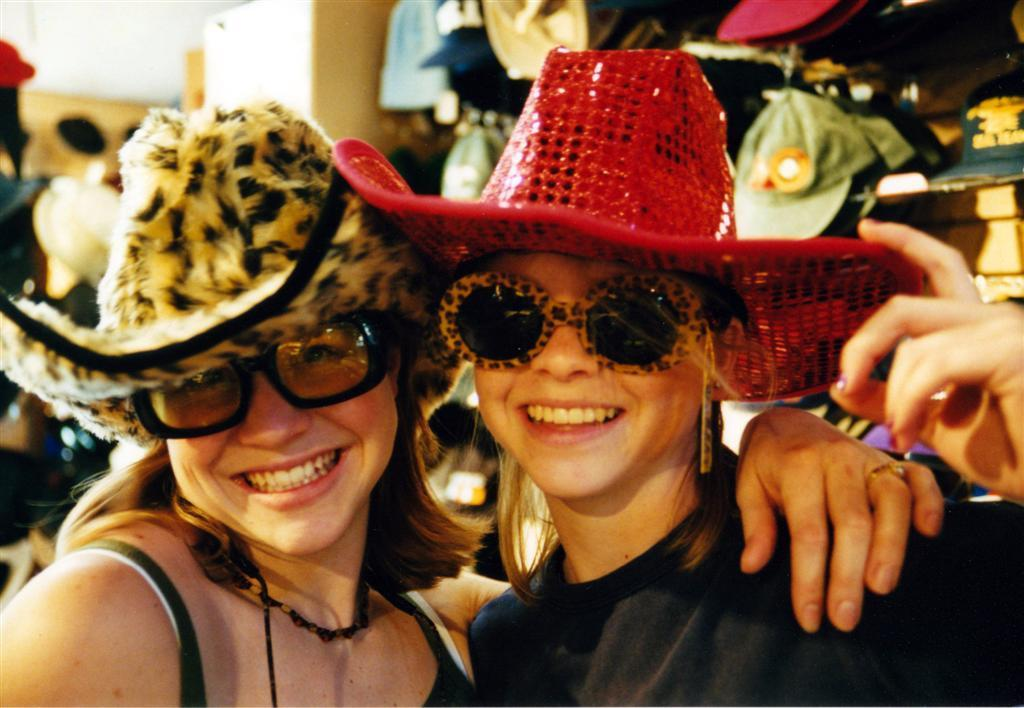How many people are in the image? There are two persons in the image. What are the persons wearing on their heads? Both persons are wearing caps. What expressions do the persons have in the image? Both persons are smiling. What type of parcel is being delivered by the persons in the image? There is no parcel visible in the image, and the persons are not delivering anything. What route are the persons taking in the image? There is no indication of a route or any movement in the image; it simply shows two people wearing caps and smiling. 